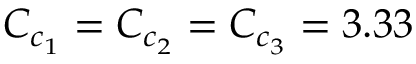Convert formula to latex. <formula><loc_0><loc_0><loc_500><loc_500>C _ { c _ { 1 } } = C _ { c _ { 2 } } = C _ { c _ { 3 } } = 3 . 3 3</formula> 